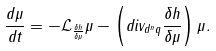<formula> <loc_0><loc_0><loc_500><loc_500>\frac { d \mu } { d t } = - \mathcal { L } _ { \frac { \delta h } { \delta \mu } } \mu - \left ( d i v _ { d ^ { n } q } \frac { \delta h } { \delta \mu } \right ) \mu .</formula> 